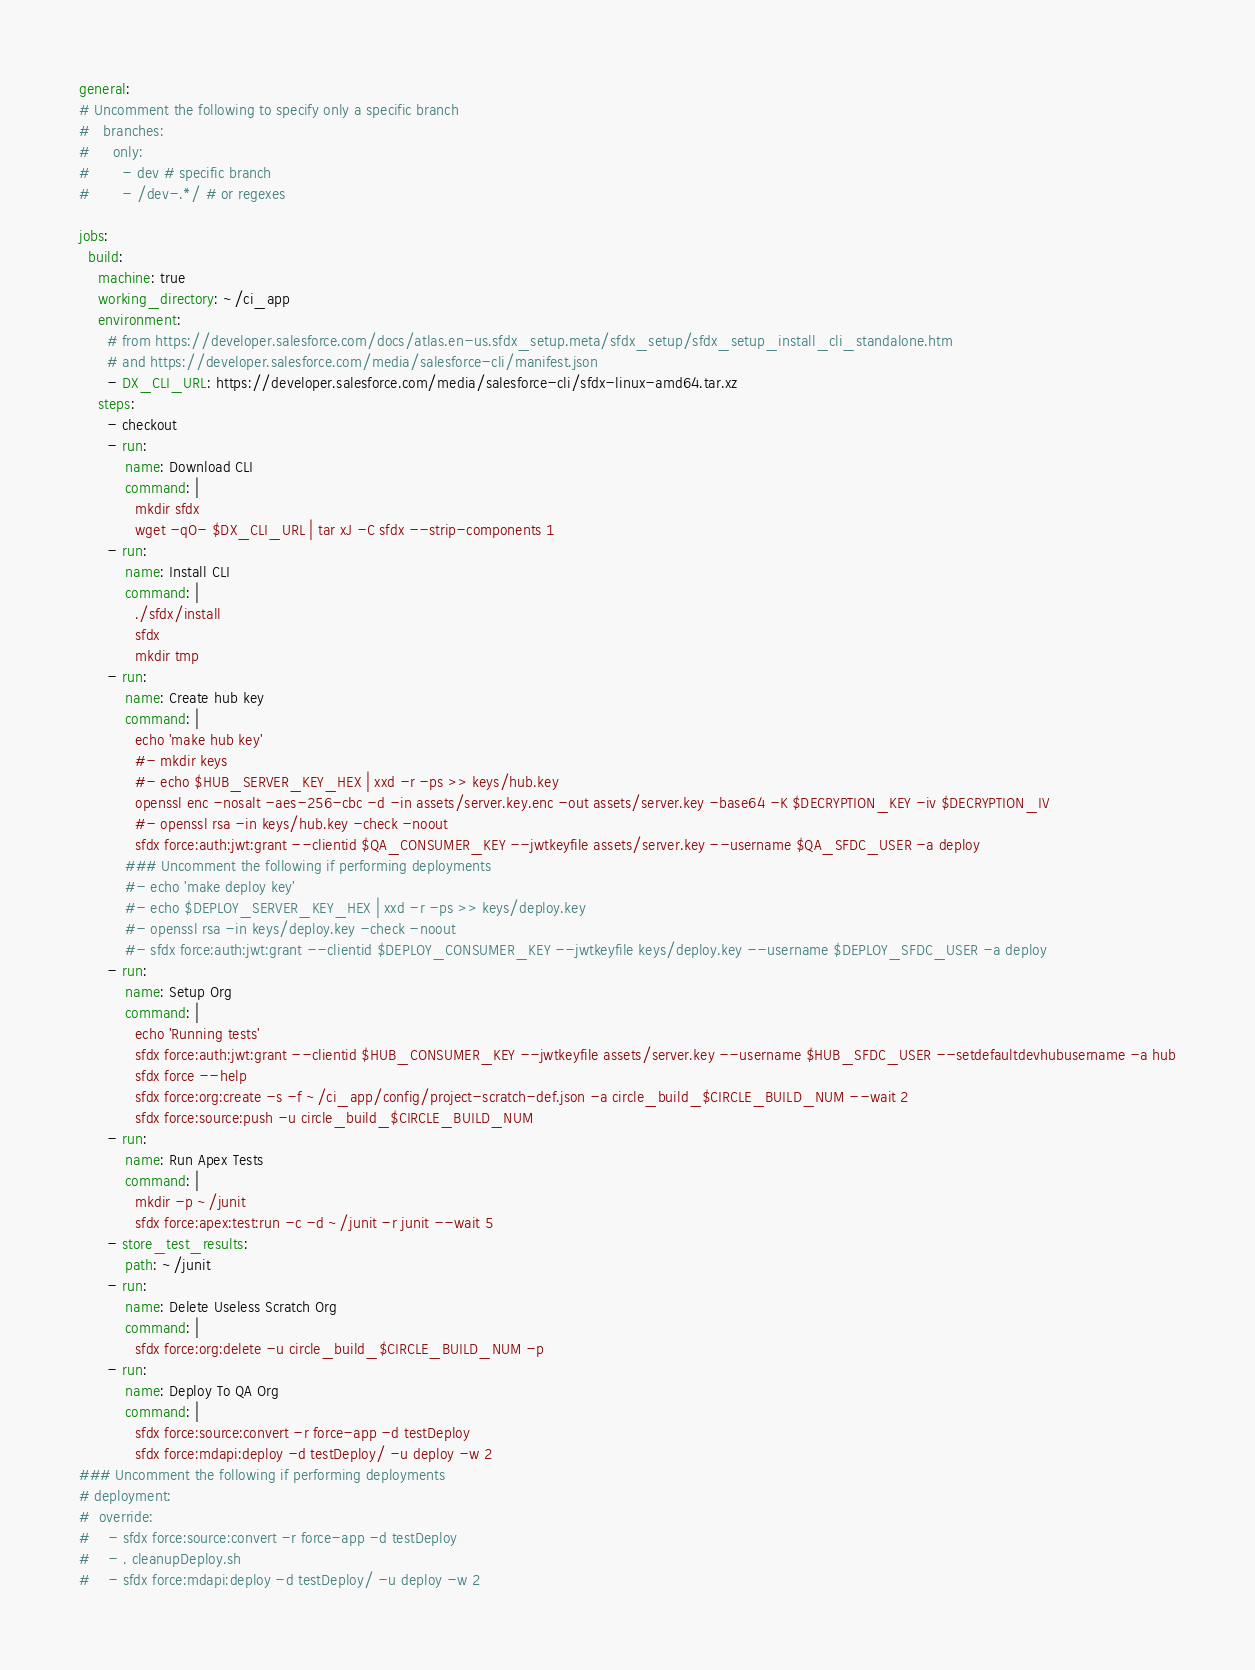Convert code to text. <code><loc_0><loc_0><loc_500><loc_500><_YAML_>
general:
# Uncomment the following to specify only a specific branch
#   branches:
#     only:
#       - dev # specific branch
#       - /dev-.*/ # or regexes

jobs:
  build:
    machine: true
    working_directory: ~/ci_app
    environment:
      # from https://developer.salesforce.com/docs/atlas.en-us.sfdx_setup.meta/sfdx_setup/sfdx_setup_install_cli_standalone.htm
      # and https://developer.salesforce.com/media/salesforce-cli/manifest.json
      - DX_CLI_URL: https://developer.salesforce.com/media/salesforce-cli/sfdx-linux-amd64.tar.xz
    steps:
      - checkout
      - run:
          name: Download CLI
          command: |
            mkdir sfdx
            wget -qO- $DX_CLI_URL | tar xJ -C sfdx --strip-components 1
      - run:
          name: Install CLI
          command: |
            ./sfdx/install
            sfdx
            mkdir tmp
      - run:
          name: Create hub key
          command: |
            echo 'make hub key'
            #- mkdir keys
            #- echo $HUB_SERVER_KEY_HEX | xxd -r -ps >> keys/hub.key
            openssl enc -nosalt -aes-256-cbc -d -in assets/server.key.enc -out assets/server.key -base64 -K $DECRYPTION_KEY -iv $DECRYPTION_IV
            #- openssl rsa -in keys/hub.key -check -noout
            sfdx force:auth:jwt:grant --clientid $QA_CONSUMER_KEY --jwtkeyfile assets/server.key --username $QA_SFDC_USER -a deploy
          ### Uncomment the following if performing deployments
          #- echo 'make deploy key'
          #- echo $DEPLOY_SERVER_KEY_HEX | xxd -r -ps >> keys/deploy.key
          #- openssl rsa -in keys/deploy.key -check -noout
          #- sfdx force:auth:jwt:grant --clientid $DEPLOY_CONSUMER_KEY --jwtkeyfile keys/deploy.key --username $DEPLOY_SFDC_USER -a deploy
      - run:
          name: Setup Org
          command: |
            echo 'Running tests'
            sfdx force:auth:jwt:grant --clientid $HUB_CONSUMER_KEY --jwtkeyfile assets/server.key --username $HUB_SFDC_USER --setdefaultdevhubusername -a hub
            sfdx force --help
            sfdx force:org:create -s -f ~/ci_app/config/project-scratch-def.json -a circle_build_$CIRCLE_BUILD_NUM --wait 2
            sfdx force:source:push -u circle_build_$CIRCLE_BUILD_NUM
      - run:
          name: Run Apex Tests
          command: |
            mkdir -p ~/junit
            sfdx force:apex:test:run -c -d ~/junit -r junit --wait 5
      - store_test_results:
          path: ~/junit
      - run:
          name: Delete Useless Scratch Org
          command: |
            sfdx force:org:delete -u circle_build_$CIRCLE_BUILD_NUM -p
      - run:
          name: Deploy To QA Org
          command: |
            sfdx force:source:convert -r force-app -d testDeploy
            sfdx force:mdapi:deploy -d testDeploy/ -u deploy -w 2
### Uncomment the following if performing deployments
# deployment:
#  override:
#    - sfdx force:source:convert -r force-app -d testDeploy
#    - . cleanupDeploy.sh
#    - sfdx force:mdapi:deploy -d testDeploy/ -u deploy -w 2
</code> 